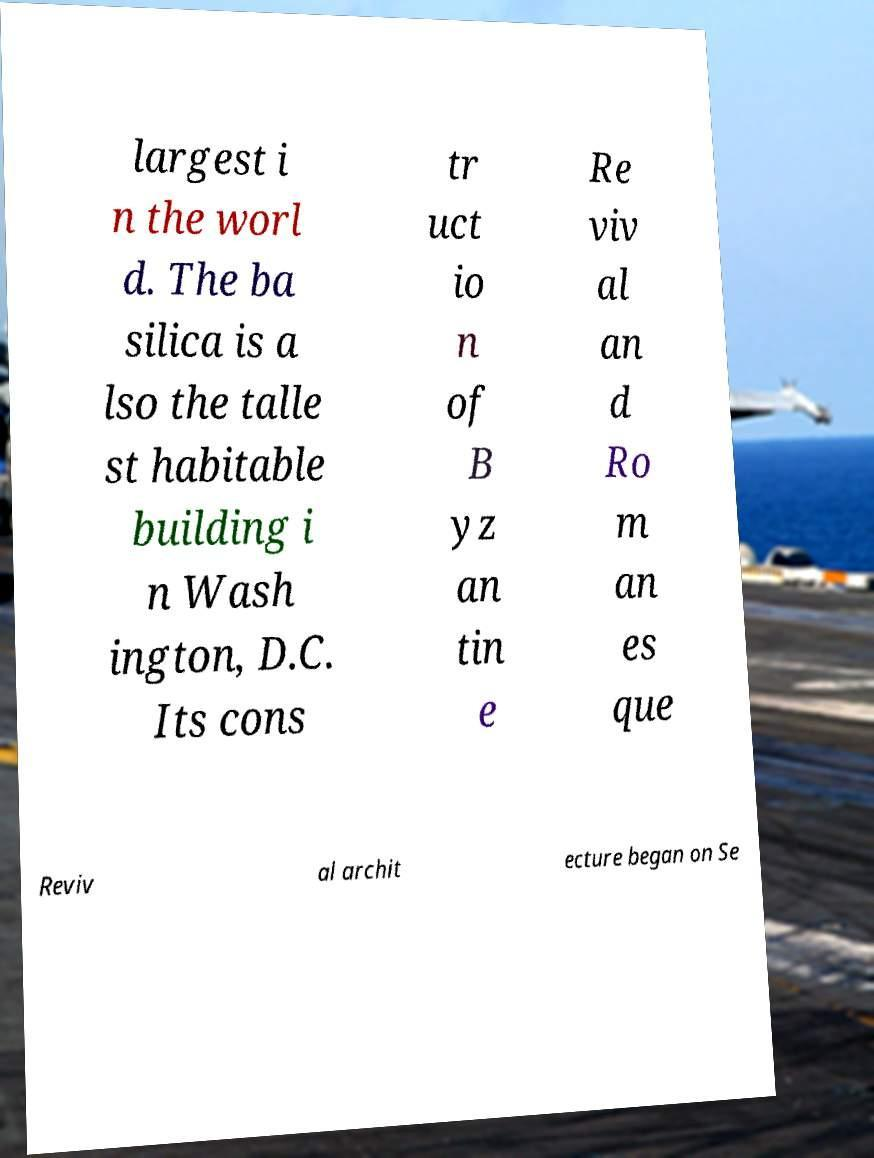Can you accurately transcribe the text from the provided image for me? largest i n the worl d. The ba silica is a lso the talle st habitable building i n Wash ington, D.C. Its cons tr uct io n of B yz an tin e Re viv al an d Ro m an es que Reviv al archit ecture began on Se 